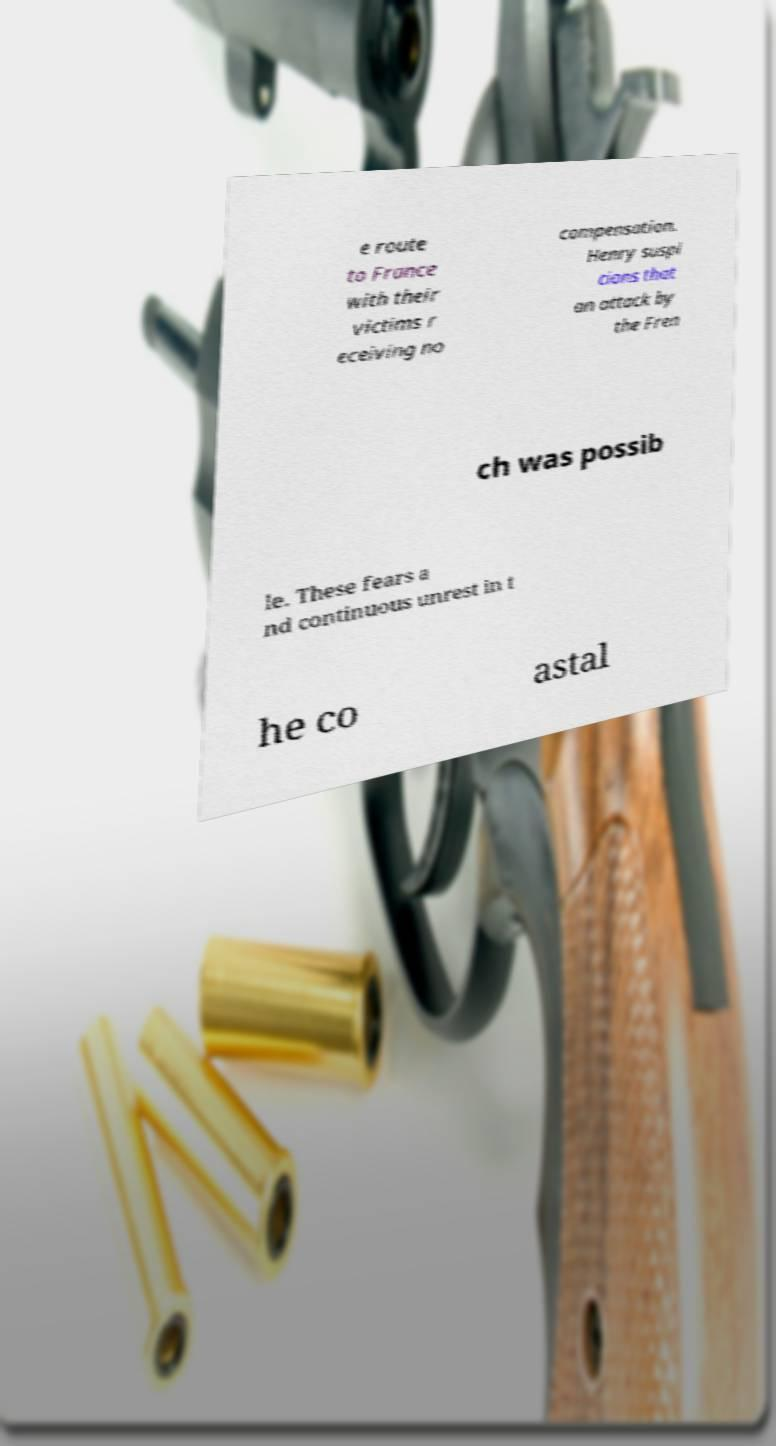Could you assist in decoding the text presented in this image and type it out clearly? e route to France with their victims r eceiving no compensation. Henry suspi cions that an attack by the Fren ch was possib le. These fears a nd continuous unrest in t he co astal 